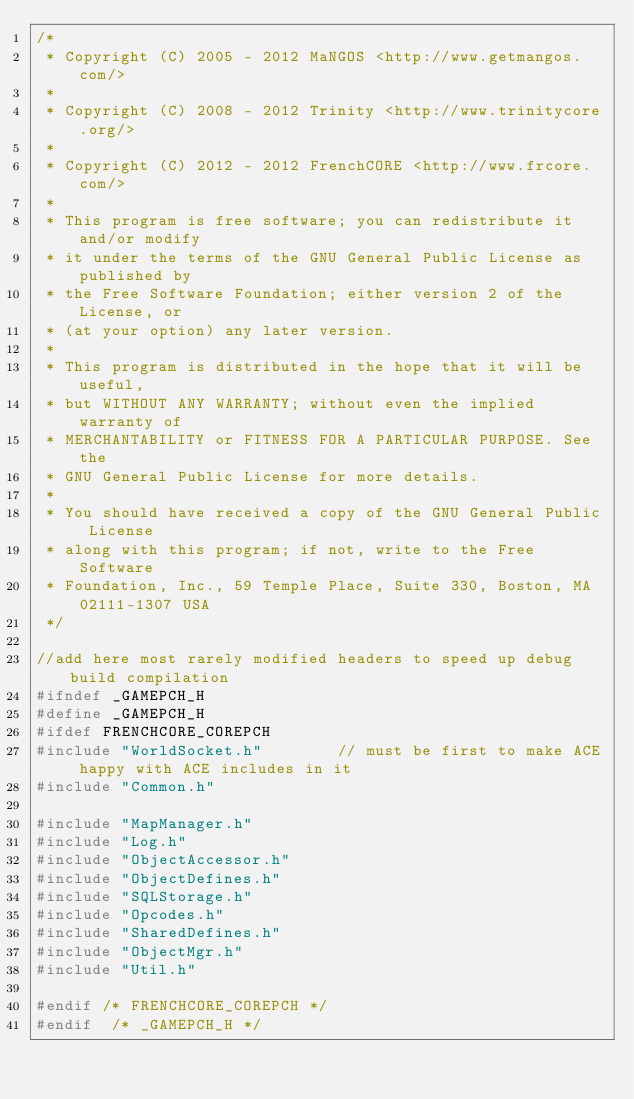<code> <loc_0><loc_0><loc_500><loc_500><_C_>/*
 * Copyright (C) 2005 - 2012 MaNGOS <http://www.getmangos.com/>
 *
 * Copyright (C) 2008 - 2012 Trinity <http://www.trinitycore.org/>
 * 
 * Copyright (C) 2012 - 2012 FrenchCORE <http://www.frcore.com/>
 *
 * This program is free software; you can redistribute it and/or modify
 * it under the terms of the GNU General Public License as published by
 * the Free Software Foundation; either version 2 of the License, or
 * (at your option) any later version.
 *
 * This program is distributed in the hope that it will be useful,
 * but WITHOUT ANY WARRANTY; without even the implied warranty of
 * MERCHANTABILITY or FITNESS FOR A PARTICULAR PURPOSE. See the
 * GNU General Public License for more details.
 *
 * You should have received a copy of the GNU General Public License
 * along with this program; if not, write to the Free Software
 * Foundation, Inc., 59 Temple Place, Suite 330, Boston, MA 02111-1307 USA
 */

//add here most rarely modified headers to speed up debug build compilation
#ifndef _GAMEPCH_H
#define _GAMEPCH_H
#ifdef FRENCHCORE_COREPCH
#include "WorldSocket.h"        // must be first to make ACE happy with ACE includes in it
#include "Common.h"

#include "MapManager.h"
#include "Log.h"
#include "ObjectAccessor.h"
#include "ObjectDefines.h"
#include "SQLStorage.h"
#include "Opcodes.h"
#include "SharedDefines.h"
#include "ObjectMgr.h"
#include "Util.h"

#endif /* FRENCHCORE_COREPCH */
#endif  /* _GAMEPCH_H */
</code> 